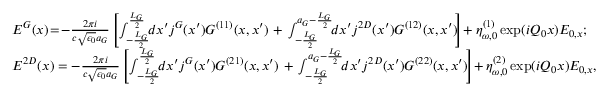Convert formula to latex. <formula><loc_0><loc_0><loc_500><loc_500>\begin{array} { r l } & { E ^ { G } ( x ) \, = \, - \frac { 2 \pi i } { c \sqrt { \epsilon _ { 0 } } a _ { G } } \left [ \int _ { - \frac { L _ { G } } { 2 } } ^ { \frac { L _ { G } } { 2 } } \, d x ^ { \prime } j ^ { G } ( x ^ { \prime } ) G ^ { ( 1 1 ) } ( x , x ^ { \prime } ) + \int _ { - \frac { L _ { G } } { 2 } } ^ { a _ { G } - \frac { L _ { G } } { 2 } } \, d x ^ { \prime } j ^ { 2 D } ( x ^ { \prime } ) G ^ { ( 1 2 ) } ( x , x ^ { \prime } ) \, \right ] \, + \eta _ { \omega , 0 } ^ { ( 1 ) } \exp ( i Q _ { 0 } x ) E _ { 0 , x } ; } \\ & { E ^ { 2 D } ( x ) = - \frac { 2 \pi i } { c \sqrt { \epsilon _ { 0 } } a _ { G } } \left [ \int _ { - \frac { L _ { G } } { 2 } } ^ { \frac { L _ { G } } { 2 } } \, d x ^ { \prime } j ^ { G } ( x ^ { \prime } ) G ^ { ( 2 1 ) } ( x , x ^ { \prime } ) + \int _ { - \frac { L _ { G } } { 2 } } ^ { a _ { G } - \frac { L _ { G } } { 2 } } \, d x ^ { \prime } j ^ { 2 D } ( x ^ { \prime } ) G ^ { ( 2 2 ) } ( x , x ^ { \prime } ) \, \right ] \, + \eta _ { \omega , 0 } ^ { ( 2 ) } \exp ( i Q _ { 0 } x ) E _ { 0 , x } , } \end{array}</formula> 